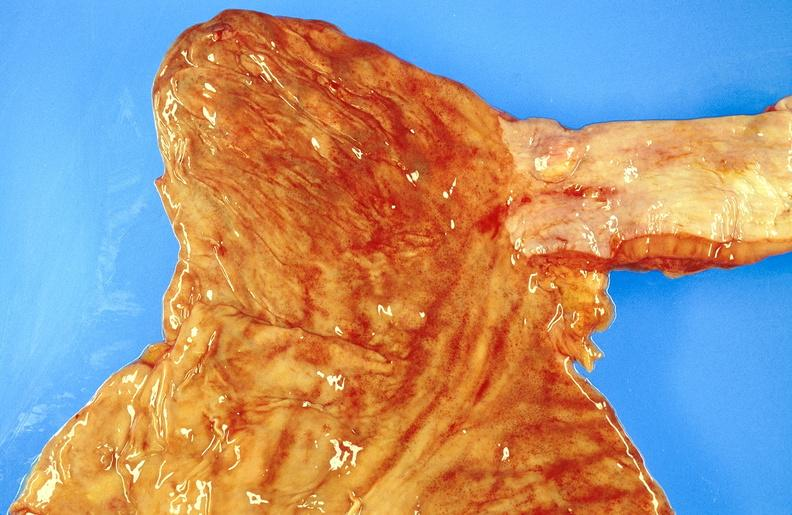does this image show esophagus, leiomyoma?
Answer the question using a single word or phrase. Yes 